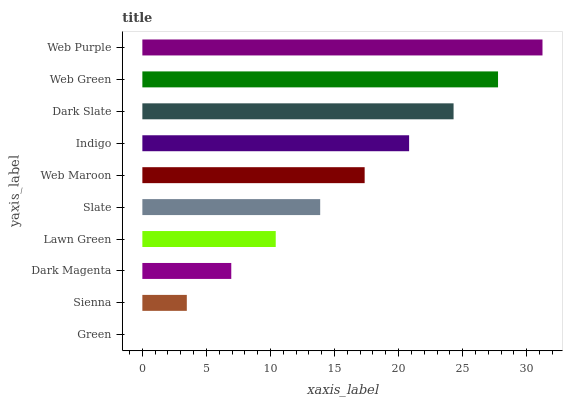Is Green the minimum?
Answer yes or no. Yes. Is Web Purple the maximum?
Answer yes or no. Yes. Is Sienna the minimum?
Answer yes or no. No. Is Sienna the maximum?
Answer yes or no. No. Is Sienna greater than Green?
Answer yes or no. Yes. Is Green less than Sienna?
Answer yes or no. Yes. Is Green greater than Sienna?
Answer yes or no. No. Is Sienna less than Green?
Answer yes or no. No. Is Web Maroon the high median?
Answer yes or no. Yes. Is Slate the low median?
Answer yes or no. Yes. Is Web Green the high median?
Answer yes or no. No. Is Dark Magenta the low median?
Answer yes or no. No. 